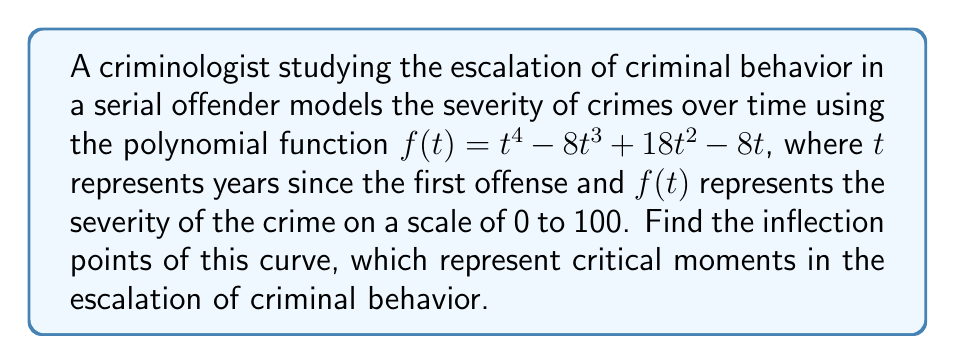Help me with this question. To find the inflection points, we need to follow these steps:

1) The inflection points occur where the second derivative of the function changes sign. So, we need to find the second derivative and set it equal to zero.

2) First, let's find the first derivative:
   $$f'(t) = 4t^3 - 24t^2 + 36t - 8$$

3) Now, let's find the second derivative:
   $$f''(t) = 12t^2 - 48t + 36$$

4) Set the second derivative equal to zero and solve for t:
   $$12t^2 - 48t + 36 = 0$$

5) This is a quadratic equation. We can solve it using the quadratic formula:
   $$t = \frac{-b \pm \sqrt{b^2 - 4ac}}{2a}$$
   where $a = 12$, $b = -48$, and $c = 36$

6) Plugging in these values:
   $$t = \frac{48 \pm \sqrt{(-48)^2 - 4(12)(36)}}{2(12)}$$
   $$= \frac{48 \pm \sqrt{2304 - 1728}}{24}$$
   $$= \frac{48 \pm \sqrt{576}}{24}$$
   $$= \frac{48 \pm 24}{24}$$

7) This gives us two solutions:
   $$t = \frac{48 + 24}{24} = 3$$ and $$t = \frac{48 - 24}{24} = 1$$

8) To confirm these are inflection points, we can check that the second derivative changes sign at these points.

Therefore, the inflection points occur at $t = 1$ and $t = 3$.
Answer: (1, f(1)) and (3, f(3)) 